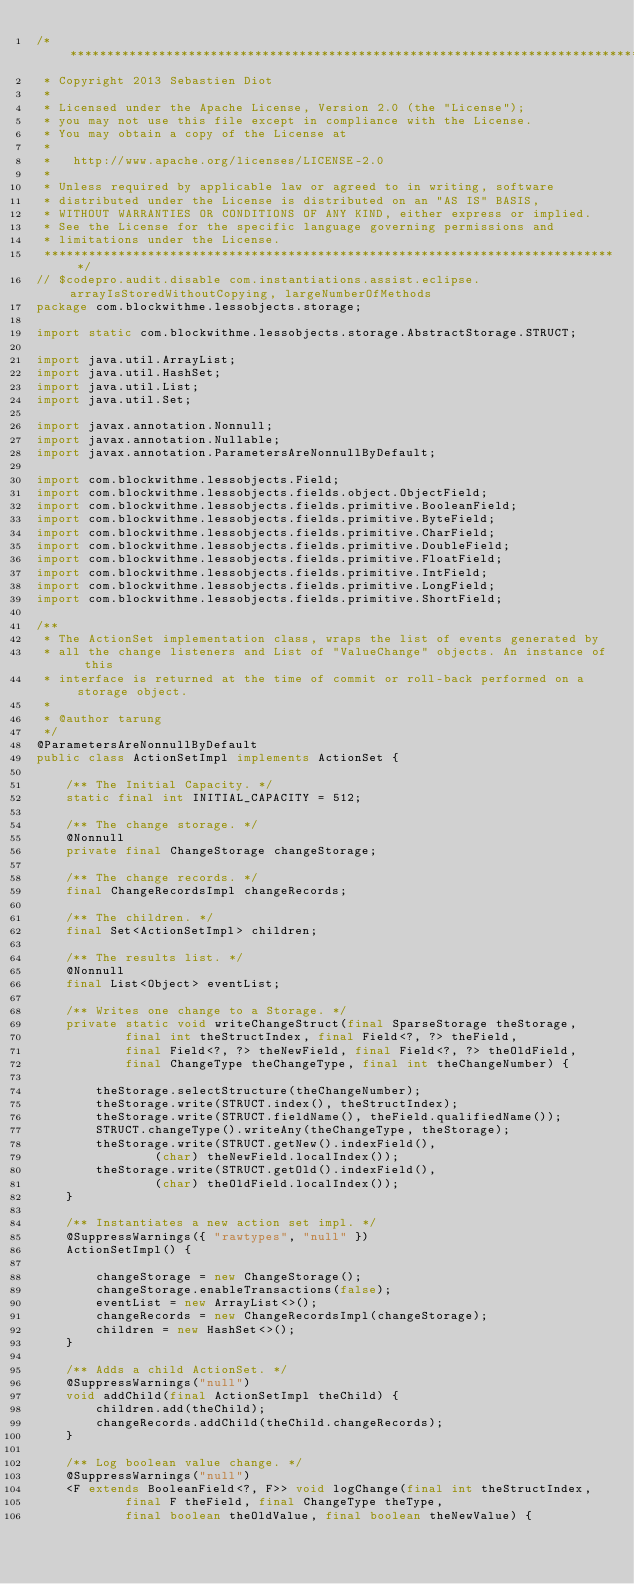<code> <loc_0><loc_0><loc_500><loc_500><_Java_>/*******************************************************************************
 * Copyright 2013 Sebastien Diot
 *
 * Licensed under the Apache License, Version 2.0 (the "License");
 * you may not use this file except in compliance with the License.
 * You may obtain a copy of the License at
 *
 *   http://www.apache.org/licenses/LICENSE-2.0
 *
 * Unless required by applicable law or agreed to in writing, software
 * distributed under the License is distributed on an "AS IS" BASIS,
 * WITHOUT WARRANTIES OR CONDITIONS OF ANY KIND, either express or implied.
 * See the License for the specific language governing permissions and
 * limitations under the License.
 ******************************************************************************/
// $codepro.audit.disable com.instantiations.assist.eclipse.arrayIsStoredWithoutCopying, largeNumberOfMethods
package com.blockwithme.lessobjects.storage;

import static com.blockwithme.lessobjects.storage.AbstractStorage.STRUCT;

import java.util.ArrayList;
import java.util.HashSet;
import java.util.List;
import java.util.Set;

import javax.annotation.Nonnull;
import javax.annotation.Nullable;
import javax.annotation.ParametersAreNonnullByDefault;

import com.blockwithme.lessobjects.Field;
import com.blockwithme.lessobjects.fields.object.ObjectField;
import com.blockwithme.lessobjects.fields.primitive.BooleanField;
import com.blockwithme.lessobjects.fields.primitive.ByteField;
import com.blockwithme.lessobjects.fields.primitive.CharField;
import com.blockwithme.lessobjects.fields.primitive.DoubleField;
import com.blockwithme.lessobjects.fields.primitive.FloatField;
import com.blockwithme.lessobjects.fields.primitive.IntField;
import com.blockwithme.lessobjects.fields.primitive.LongField;
import com.blockwithme.lessobjects.fields.primitive.ShortField;

/**
 * The ActionSet implementation class, wraps the list of events generated by
 * all the change listeners and List of "ValueChange" objects. An instance of this
 * interface is returned at the time of commit or roll-back performed on a storage object.
 *
 * @author tarung
 */
@ParametersAreNonnullByDefault
public class ActionSetImpl implements ActionSet {

    /** The Initial Capacity. */
    static final int INITIAL_CAPACITY = 512;

    /** The change storage. */
    @Nonnull
    private final ChangeStorage changeStorage;

    /** The change records. */
    final ChangeRecordsImpl changeRecords;

    /** The children. */
    final Set<ActionSetImpl> children;

    /** The results list. */
    @Nonnull
    final List<Object> eventList;

    /** Writes one change to a Storage. */
    private static void writeChangeStruct(final SparseStorage theStorage,
            final int theStructIndex, final Field<?, ?> theField,
            final Field<?, ?> theNewField, final Field<?, ?> theOldField,
            final ChangeType theChangeType, final int theChangeNumber) {

        theStorage.selectStructure(theChangeNumber);
        theStorage.write(STRUCT.index(), theStructIndex);
        theStorage.write(STRUCT.fieldName(), theField.qualifiedName());
        STRUCT.changeType().writeAny(theChangeType, theStorage);
        theStorage.write(STRUCT.getNew().indexField(),
                (char) theNewField.localIndex());
        theStorage.write(STRUCT.getOld().indexField(),
                (char) theOldField.localIndex());
    }

    /** Instantiates a new action set impl. */
    @SuppressWarnings({ "rawtypes", "null" })
    ActionSetImpl() {

        changeStorage = new ChangeStorage();
        changeStorage.enableTransactions(false);
        eventList = new ArrayList<>();
        changeRecords = new ChangeRecordsImpl(changeStorage);
        children = new HashSet<>();
    }

    /** Adds a child ActionSet. */
    @SuppressWarnings("null")
    void addChild(final ActionSetImpl theChild) {
        children.add(theChild);
        changeRecords.addChild(theChild.changeRecords);
    }

    /** Log boolean value change. */
    @SuppressWarnings("null")
    <F extends BooleanField<?, F>> void logChange(final int theStructIndex,
            final F theField, final ChangeType theType,
            final boolean theOldValue, final boolean theNewValue) {</code> 